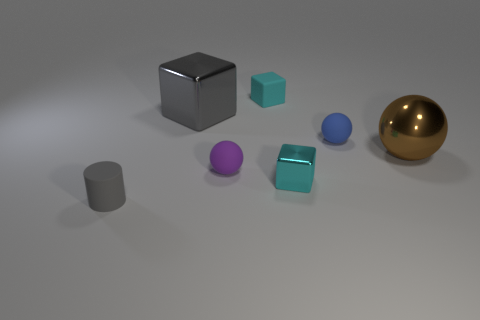Subtract 1 balls. How many balls are left? 2 Subtract all red spheres. How many cyan blocks are left? 2 Subtract all cyan blocks. How many blocks are left? 1 Add 3 large brown spheres. How many objects exist? 10 Subtract all cubes. How many objects are left? 4 Add 6 small cyan matte blocks. How many small cyan matte blocks exist? 7 Subtract 0 red cylinders. How many objects are left? 7 Subtract all tiny rubber cubes. Subtract all tiny metal things. How many objects are left? 5 Add 6 big objects. How many big objects are left? 8 